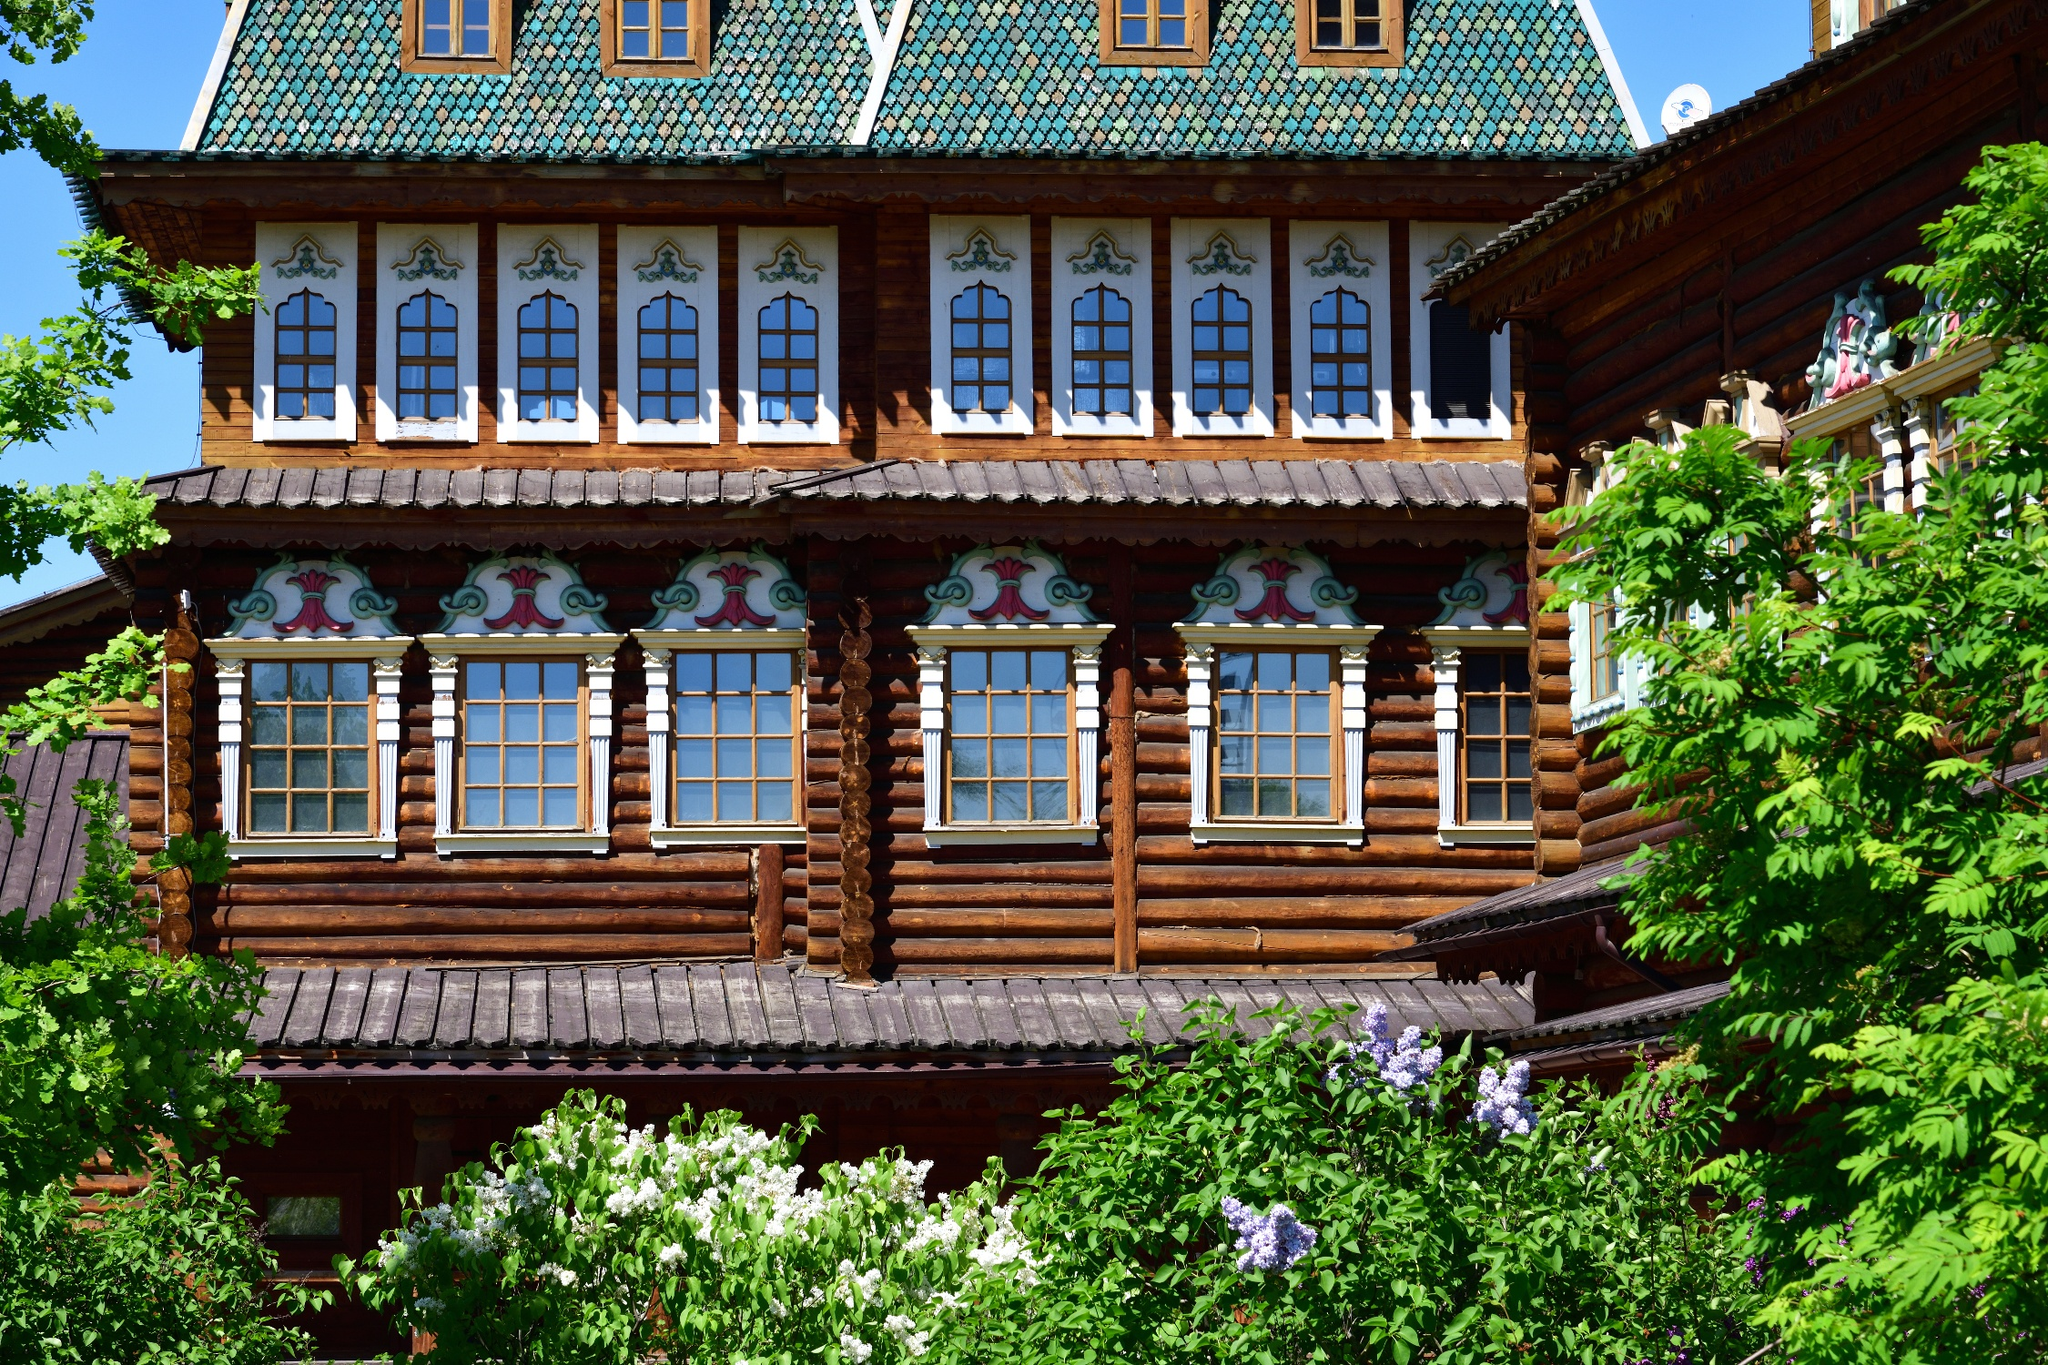What details can you provide about the architectural style seen in this image? The architectural style of this palace is characterized by its ornate woodwork and vibrant color schemes, a hallmark of traditional Russian design. The structure features carved wooden details, including window frames and eaves, which are painstakingly decorated with patterns and motifs that draw on nature and geometric shapes. The overhanging roof and the layered, horizontal logs used to build the palace showcase the 'izba' style typical in Russian wooden architecture. Additionally, the use of bright, contrasting colors in the embellishments serves both decorative and protective purposes against the elements. 